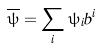Convert formula to latex. <formula><loc_0><loc_0><loc_500><loc_500>\overline { \psi } = \sum _ { i } \psi _ { i } b ^ { i }</formula> 